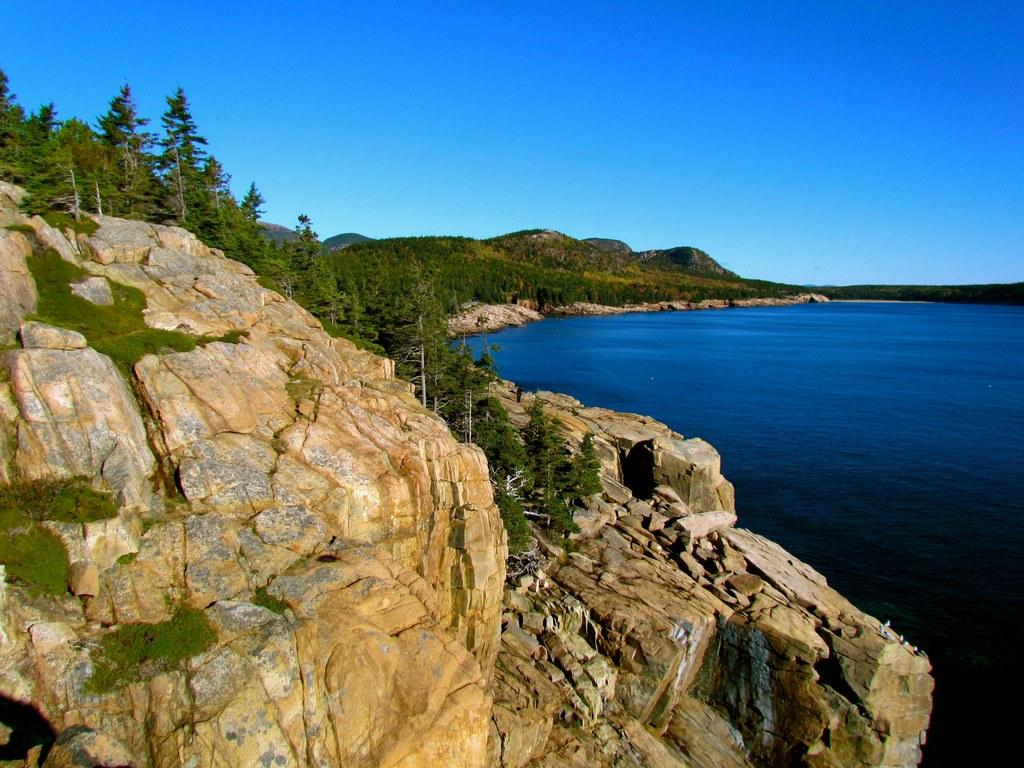What type of natural landform can be seen in the image? There are mountains in the image. What other natural elements are present in the image? There are trees and a river in the image. What part of the natural environment is visible in the image? The sky is visible in the image. How many tomatoes are growing on the trees in the image? There are no tomatoes present in the image, as the trees are not fruit-bearing trees. What shape is the river in the image? The shape of the river cannot be determined from the image alone, as it is a two-dimensional representation. 